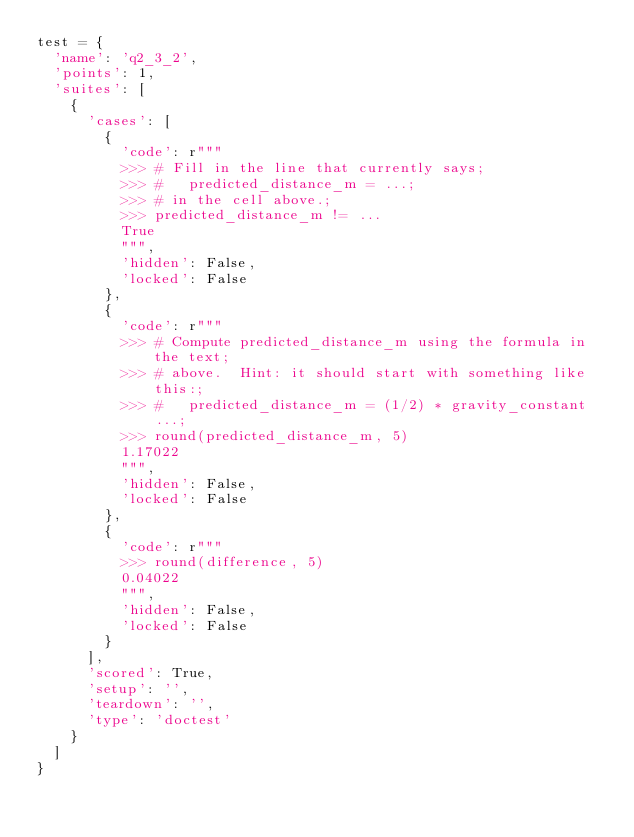<code> <loc_0><loc_0><loc_500><loc_500><_Python_>test = {
  'name': 'q2_3_2',
  'points': 1,
  'suites': [
    {
      'cases': [
        {
          'code': r"""
          >>> # Fill in the line that currently says;
          >>> #   predicted_distance_m = ...;
          >>> # in the cell above.;
          >>> predicted_distance_m != ...
          True
          """,
          'hidden': False,
          'locked': False
        },
        {
          'code': r"""
          >>> # Compute predicted_distance_m using the formula in the text;
          >>> # above.  Hint: it should start with something like this:;
          >>> #   predicted_distance_m = (1/2) * gravity_constant ...;
          >>> round(predicted_distance_m, 5)
          1.17022
          """,
          'hidden': False,
          'locked': False
        },
        {
          'code': r"""
          >>> round(difference, 5)
          0.04022
          """,
          'hidden': False,
          'locked': False
        }
      ],
      'scored': True,
      'setup': '',
      'teardown': '',
      'type': 'doctest'
    }
  ]
}
</code> 